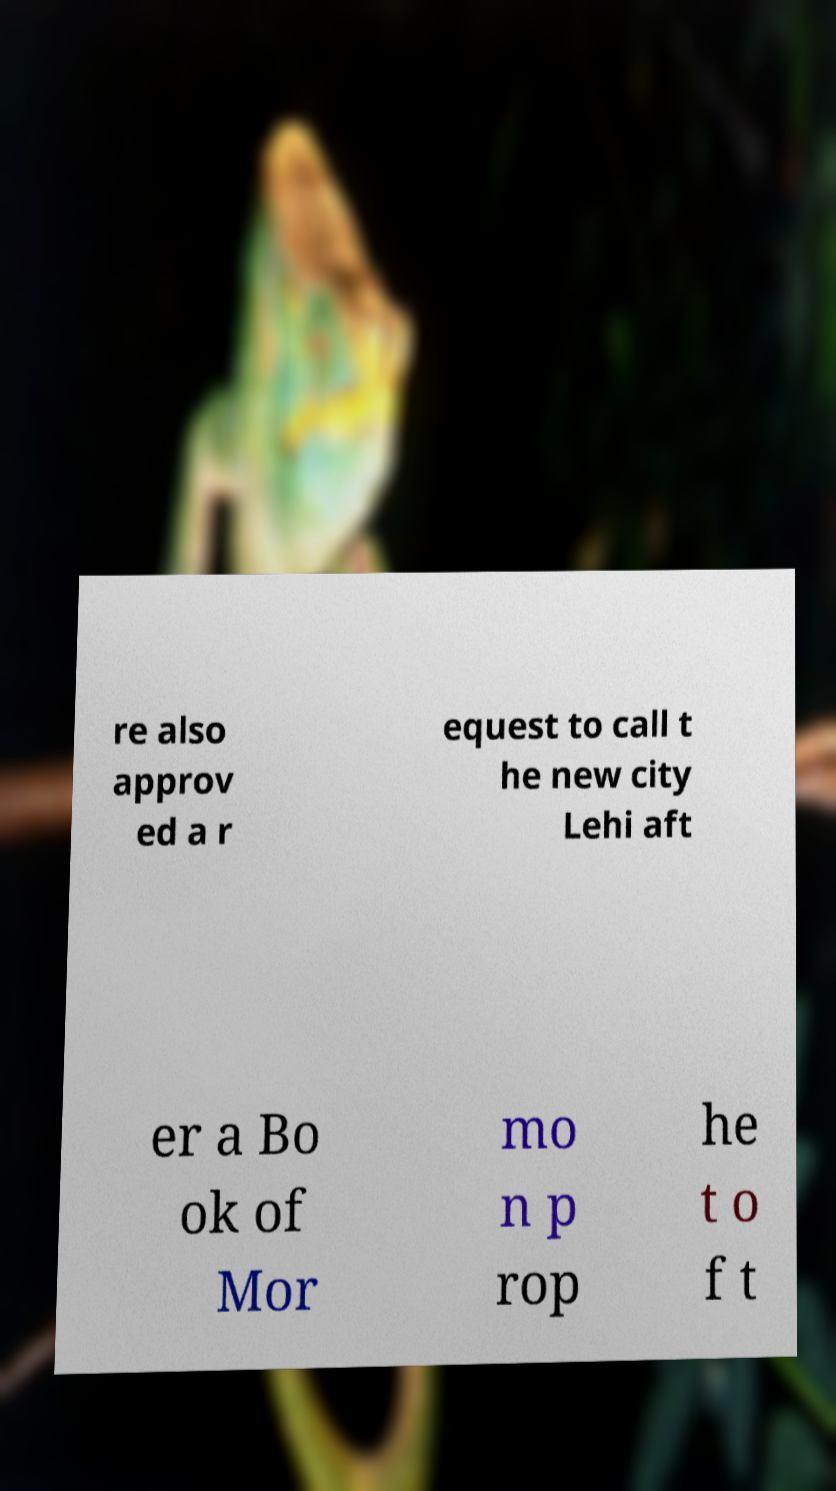I need the written content from this picture converted into text. Can you do that? re also approv ed a r equest to call t he new city Lehi aft er a Bo ok of Mor mo n p rop he t o f t 